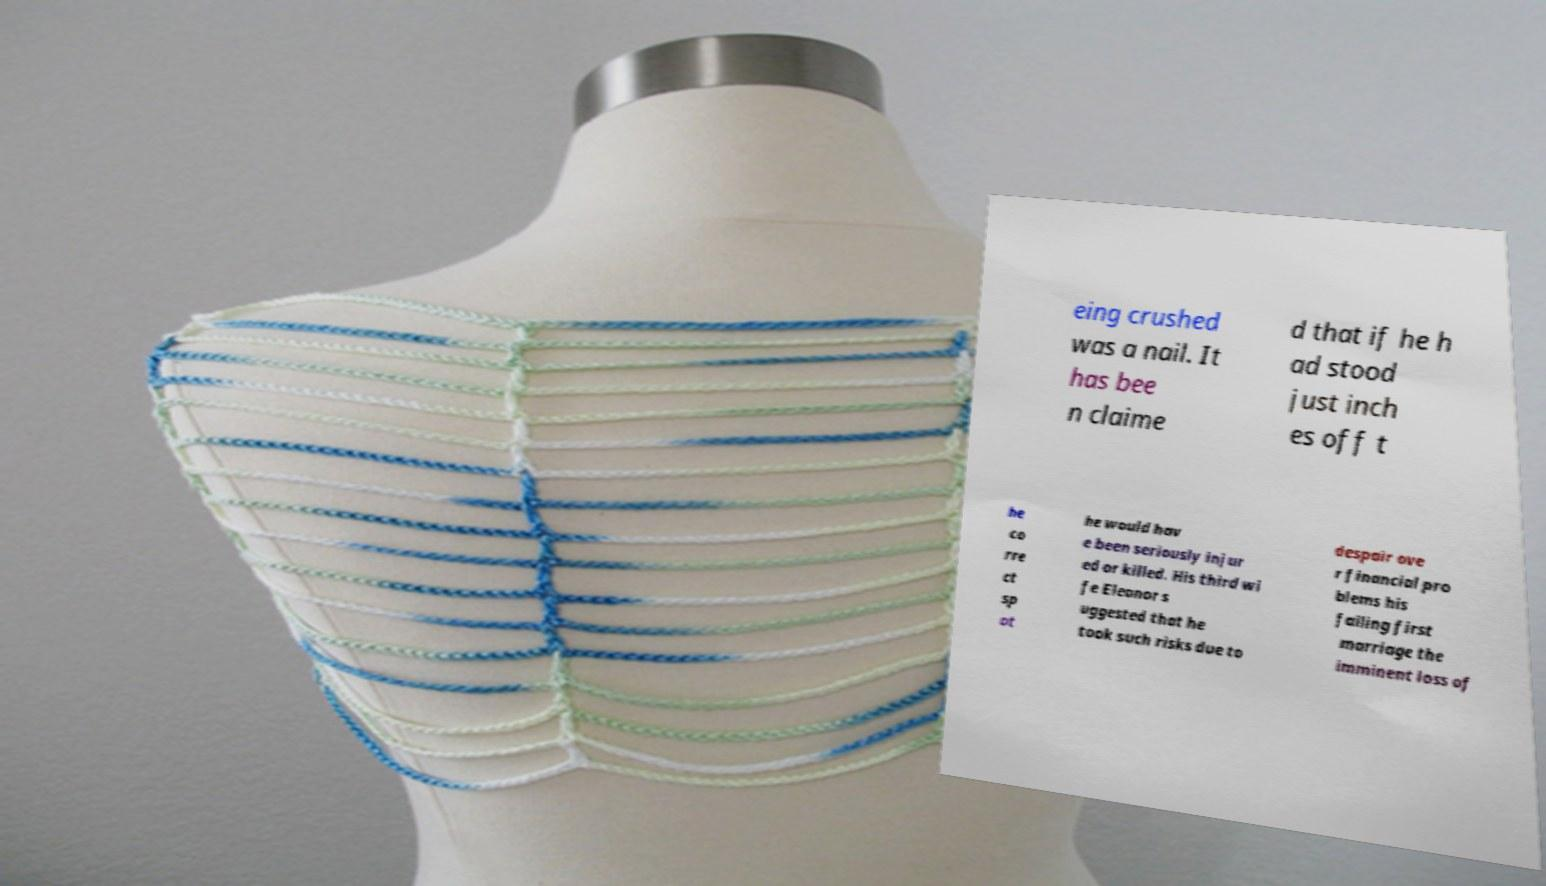Can you read and provide the text displayed in the image?This photo seems to have some interesting text. Can you extract and type it out for me? eing crushed was a nail. It has bee n claime d that if he h ad stood just inch es off t he co rre ct sp ot he would hav e been seriously injur ed or killed. His third wi fe Eleanor s uggested that he took such risks due to despair ove r financial pro blems his failing first marriage the imminent loss of 